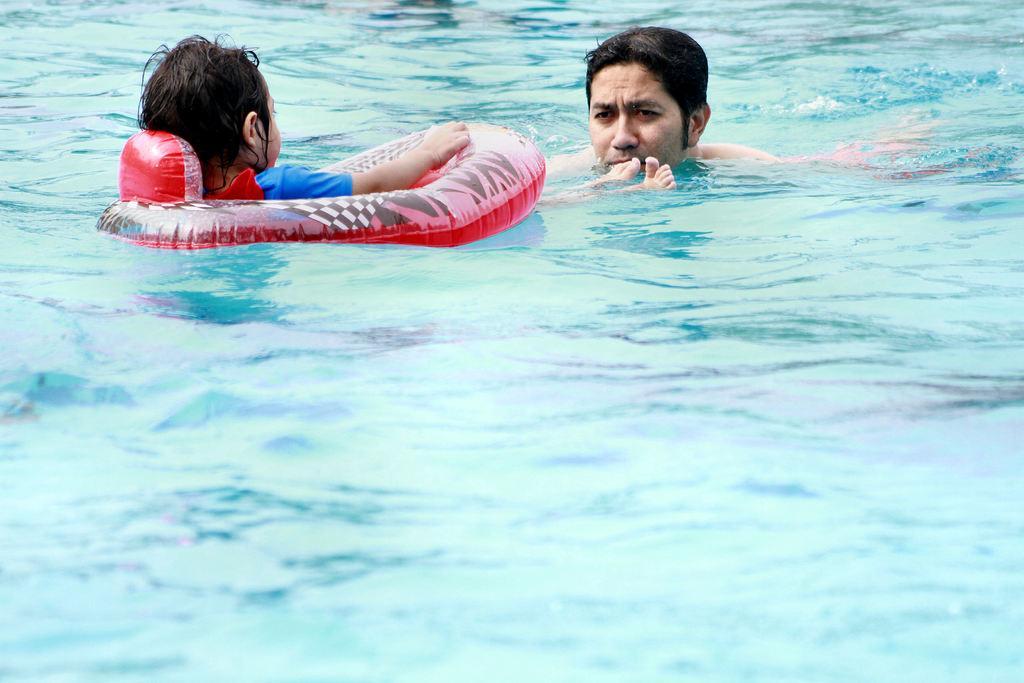Could you give a brief overview of what you see in this image? In this image we can see a child is sitting in a tube and this person, are swimming in the water. 